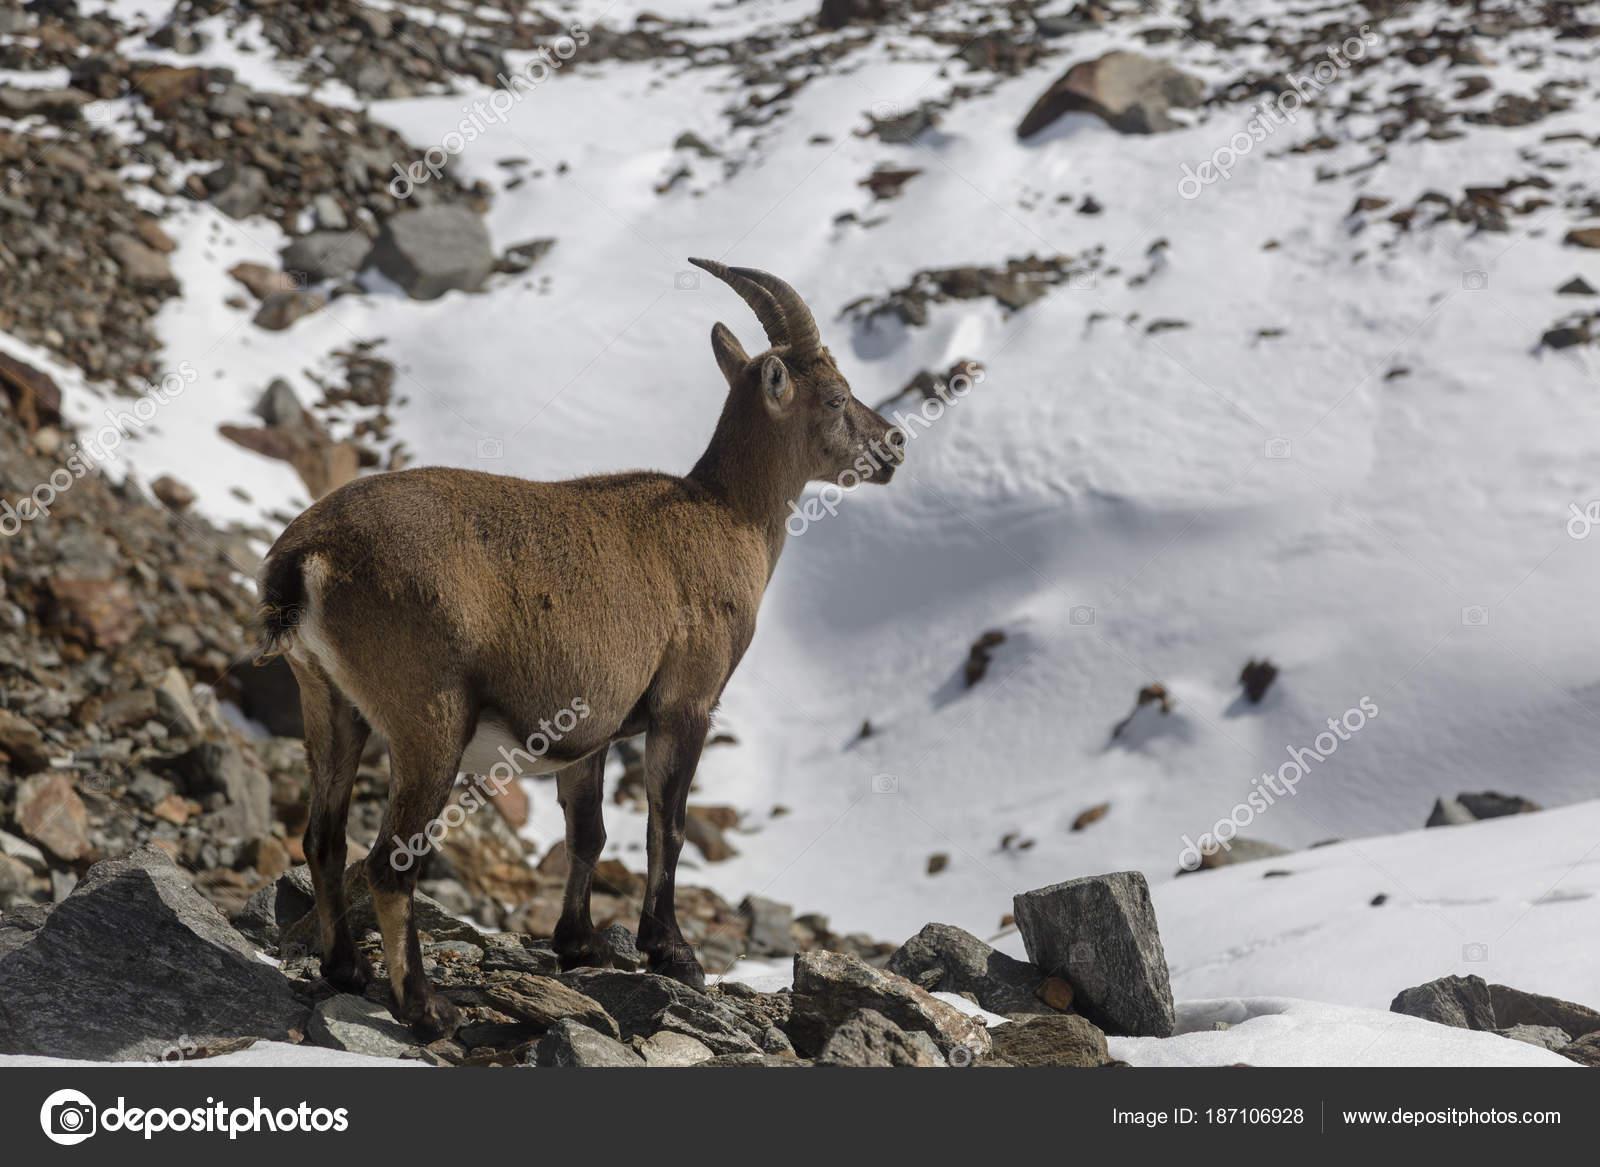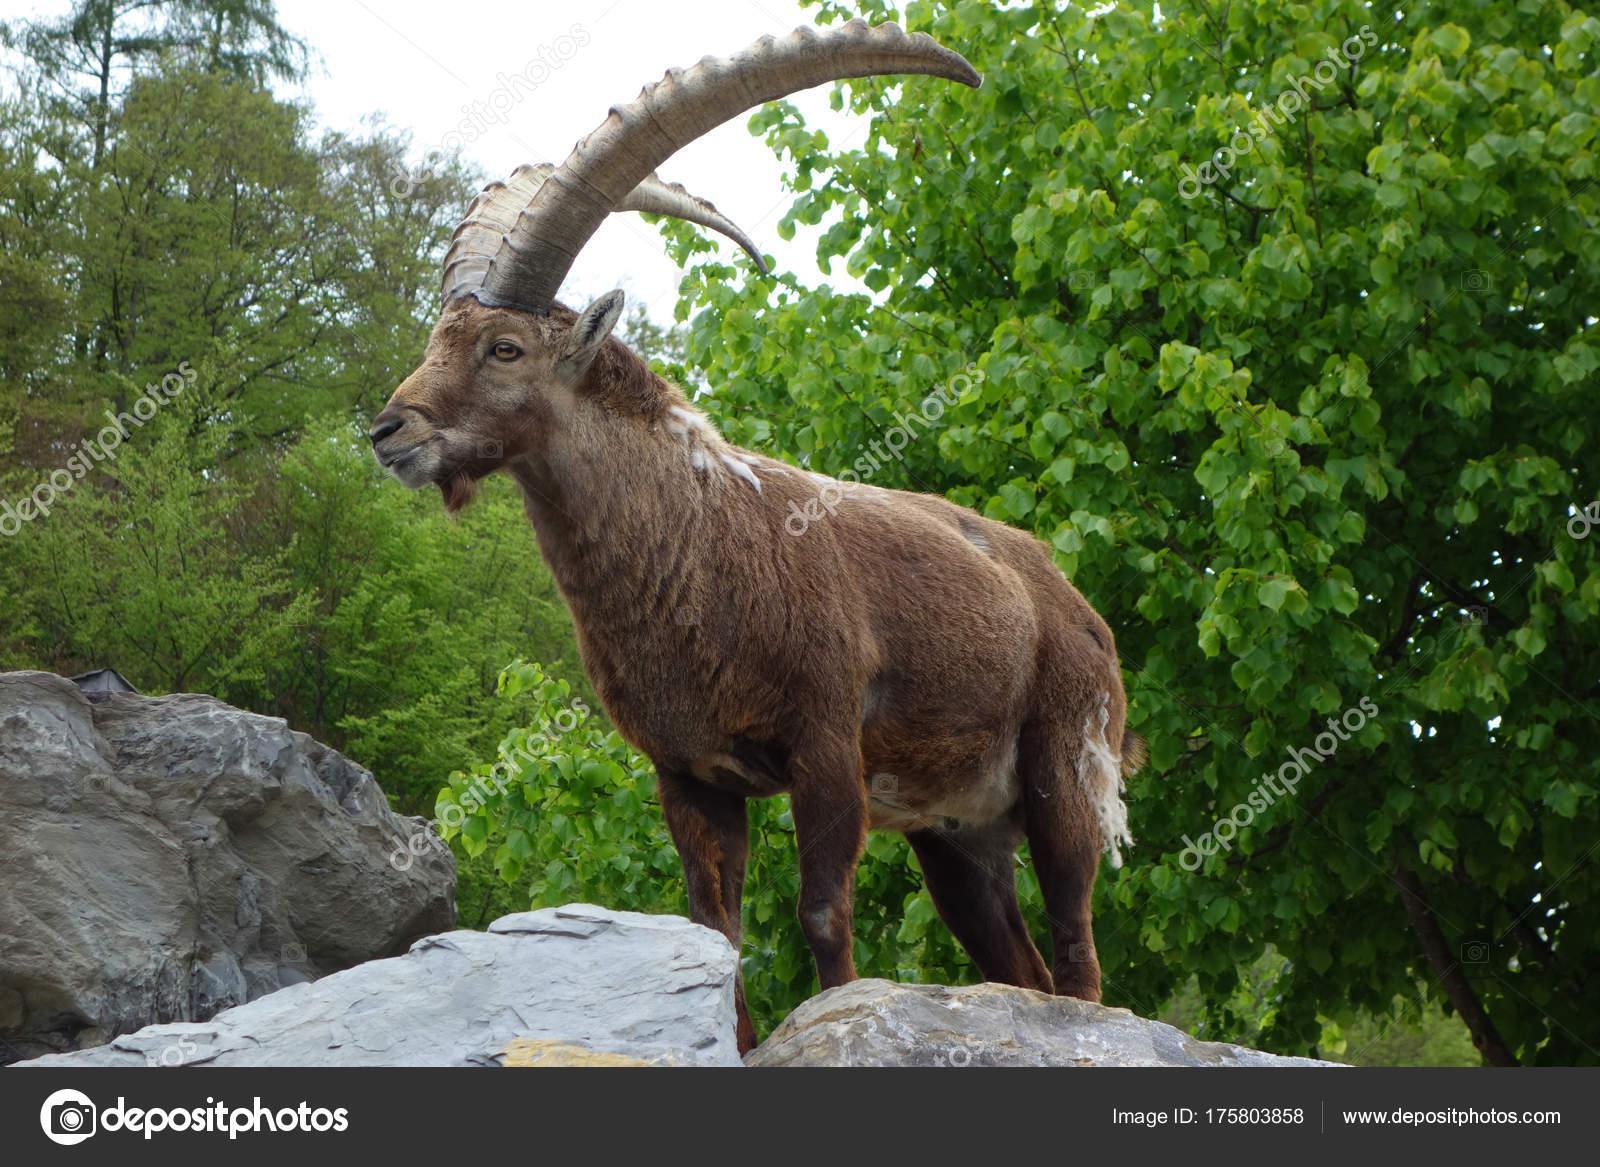The first image is the image on the left, the second image is the image on the right. Assess this claim about the two images: "The left and right image contains the same number of goats.". Correct or not? Answer yes or no. Yes. The first image is the image on the left, the second image is the image on the right. Assess this claim about the two images: "One image contains one horned animal with its head in profile facing right, and the other image includes two hooved animals.". Correct or not? Answer yes or no. No. 